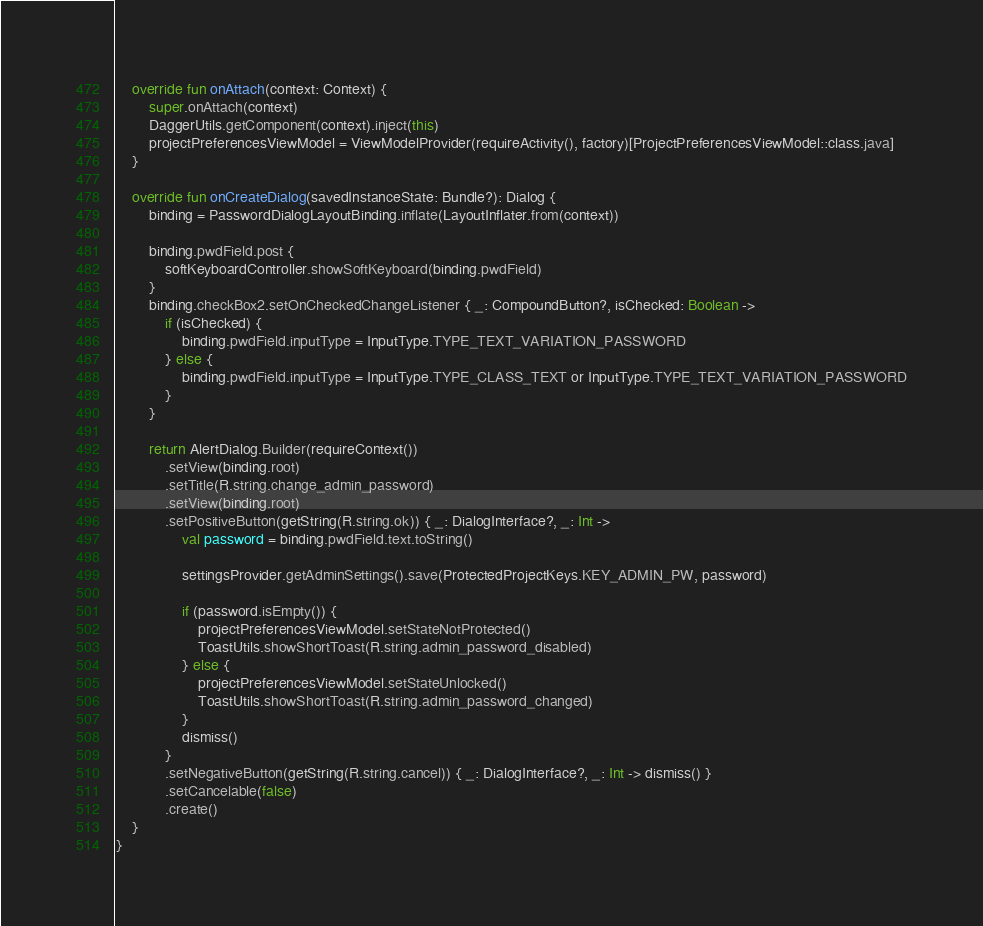<code> <loc_0><loc_0><loc_500><loc_500><_Kotlin_>
    override fun onAttach(context: Context) {
        super.onAttach(context)
        DaggerUtils.getComponent(context).inject(this)
        projectPreferencesViewModel = ViewModelProvider(requireActivity(), factory)[ProjectPreferencesViewModel::class.java]
    }

    override fun onCreateDialog(savedInstanceState: Bundle?): Dialog {
        binding = PasswordDialogLayoutBinding.inflate(LayoutInflater.from(context))

        binding.pwdField.post {
            softKeyboardController.showSoftKeyboard(binding.pwdField)
        }
        binding.checkBox2.setOnCheckedChangeListener { _: CompoundButton?, isChecked: Boolean ->
            if (isChecked) {
                binding.pwdField.inputType = InputType.TYPE_TEXT_VARIATION_PASSWORD
            } else {
                binding.pwdField.inputType = InputType.TYPE_CLASS_TEXT or InputType.TYPE_TEXT_VARIATION_PASSWORD
            }
        }

        return AlertDialog.Builder(requireContext())
            .setView(binding.root)
            .setTitle(R.string.change_admin_password)
            .setView(binding.root)
            .setPositiveButton(getString(R.string.ok)) { _: DialogInterface?, _: Int ->
                val password = binding.pwdField.text.toString()

                settingsProvider.getAdminSettings().save(ProtectedProjectKeys.KEY_ADMIN_PW, password)

                if (password.isEmpty()) {
                    projectPreferencesViewModel.setStateNotProtected()
                    ToastUtils.showShortToast(R.string.admin_password_disabled)
                } else {
                    projectPreferencesViewModel.setStateUnlocked()
                    ToastUtils.showShortToast(R.string.admin_password_changed)
                }
                dismiss()
            }
            .setNegativeButton(getString(R.string.cancel)) { _: DialogInterface?, _: Int -> dismiss() }
            .setCancelable(false)
            .create()
    }
}
</code> 